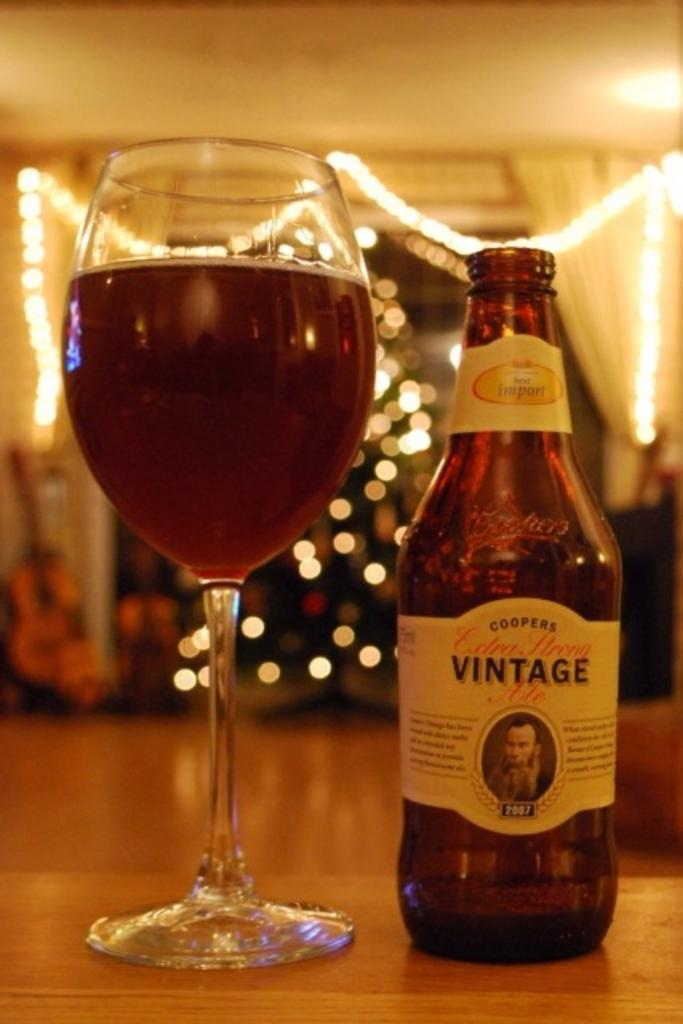What is present in the image that can hold liquid? There is a glass in the image that can hold liquid. What else can hold liquid in the image? There is a bottle in the image that can also hold liquid. What is inside the glass in the image? There is liquid in the glass. What can be seen in the middle of the image? There are lights in the middle of the image. What type of design can be seen on the dolls in the image? There are no dolls present in the image, so there is no design to observe. 